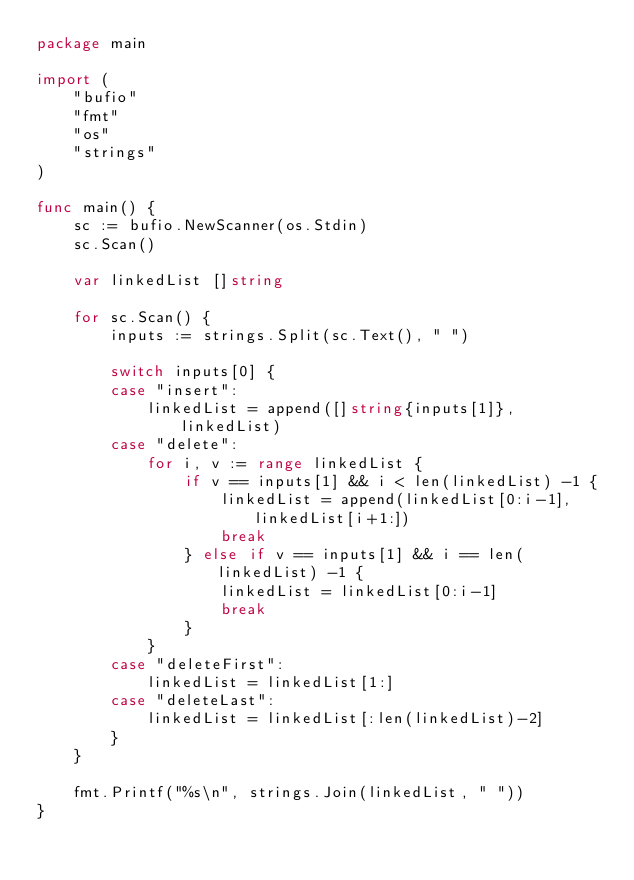Convert code to text. <code><loc_0><loc_0><loc_500><loc_500><_Go_>package main

import (
	"bufio"
	"fmt"
	"os"
	"strings"
)

func main() {
	sc := bufio.NewScanner(os.Stdin)
	sc.Scan()

	var linkedList []string

	for sc.Scan() {
		inputs := strings.Split(sc.Text(), " ")

		switch inputs[0] {
		case "insert":
			linkedList = append([]string{inputs[1]}, linkedList)
		case "delete":
			for i, v := range linkedList {
				if v == inputs[1] && i < len(linkedList) -1 {
					linkedList = append(linkedList[0:i-1], linkedList[i+1:])
					break
				} else if v == inputs[1] && i == len(linkedList) -1 {
					linkedList = linkedList[0:i-1]
					break
				}
			}
		case "deleteFirst":
			linkedList = linkedList[1:]
		case "deleteLast":
			linkedList = linkedList[:len(linkedList)-2]
		}
	}

	fmt.Printf("%s\n", strings.Join(linkedList, " "))
}
</code> 